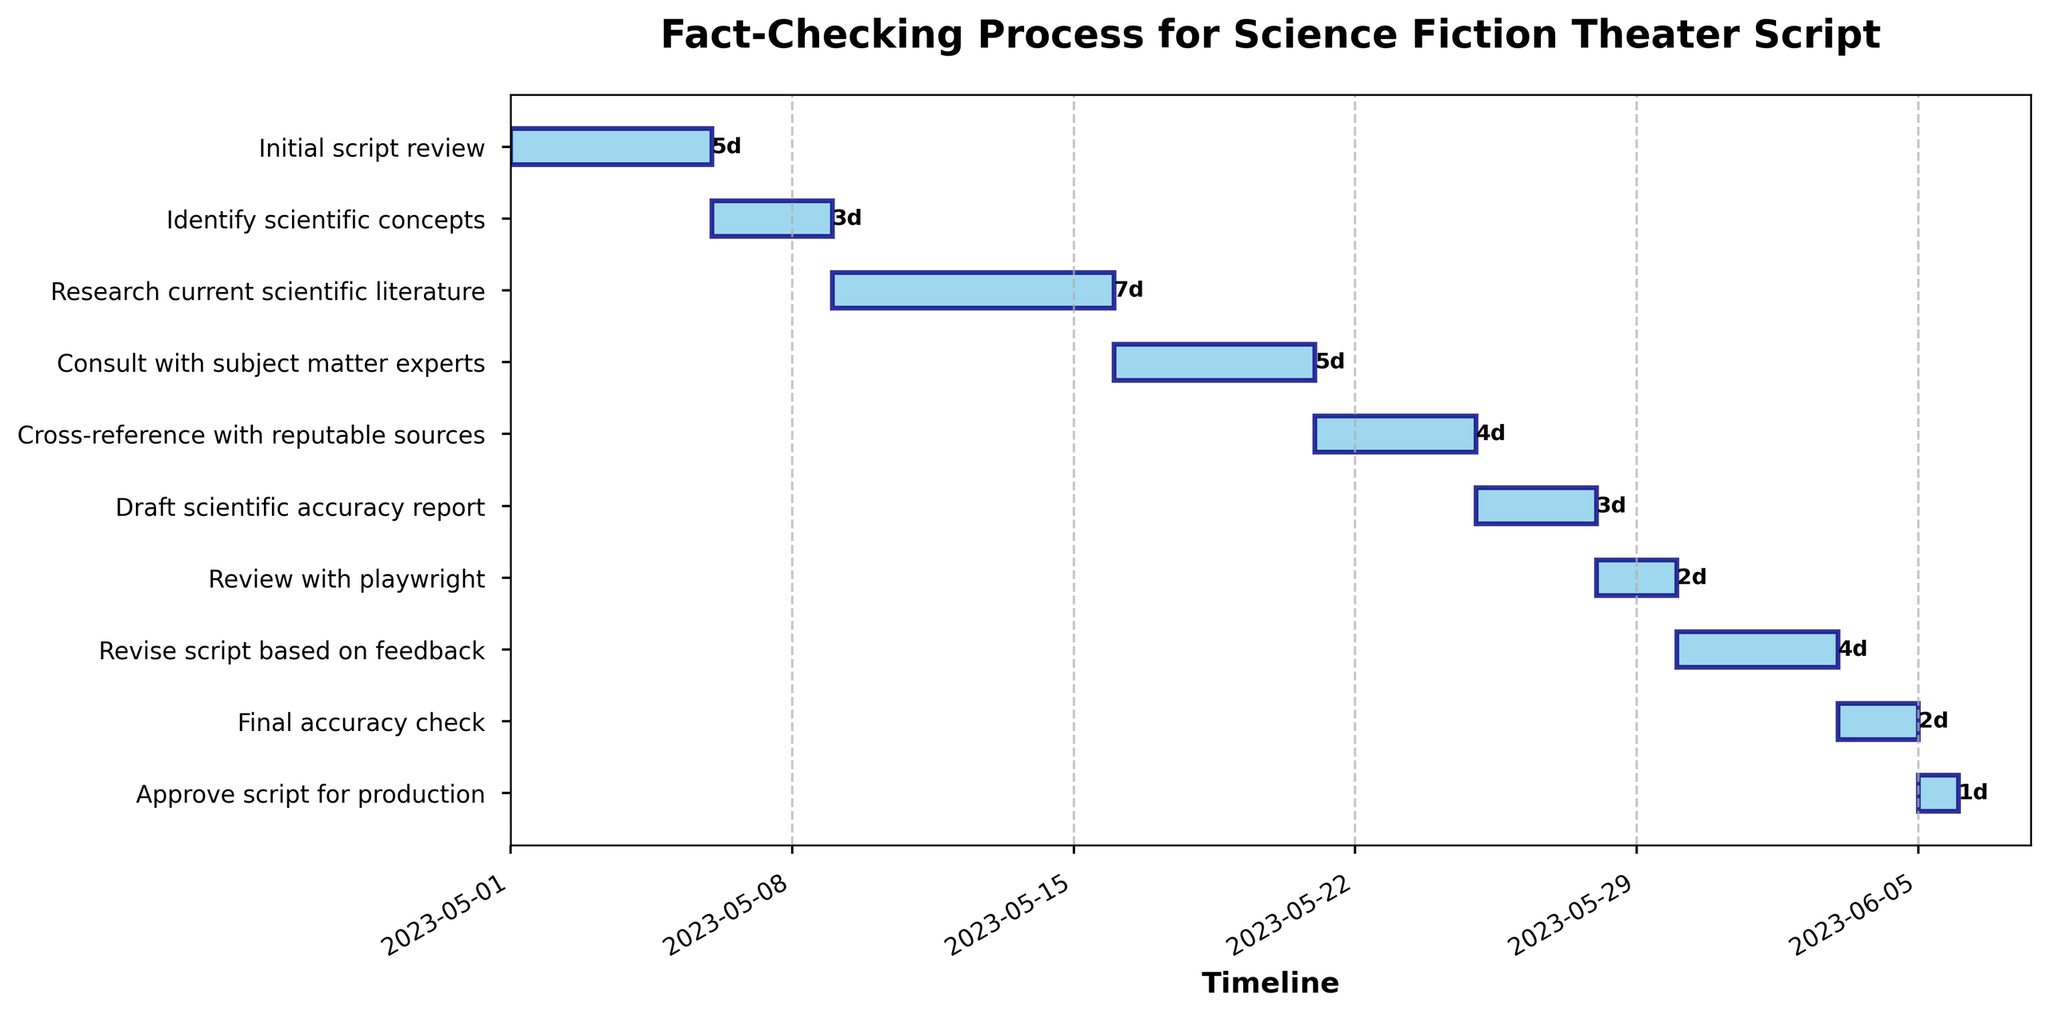What is the title of the Gantt chart? The title is found at the top of the chart and reads "Fact-Checking Process for Science Fiction Theater Script".
Answer: Fact-Checking Process for Science Fiction Theater Script What color are the bars representing each stage of the process? The bars are mostly light blue with some transparency.
Answer: light blue How many tasks are shown in the chart? There are 10 tasks, as indicated by the number of horizontal bars.
Answer: 10 When does the "Initial script review" task start? The task starts on May 1, 2023, as read from the chart's timeline and the label on the y-axis.
Answer: May 1, 2023 Which task has the longest duration? "Research current scientific literature" has the longest duration as its bar is the longest.
Answer: Research current scientific literature What is the start date of the "Final accuracy check"? The start date can be found by locating the "Final accuracy check" bar, which starts on June 3, 2023.
Answer: June 3, 2023 Which tasks take exactly 3 days to complete? By examining the duration labels on the right side of the bars, "Identify scientific concepts" and "Draft scientific accuracy report" both take 3 days.
Answer: Identify scientific concepts, Draft scientific accuracy report Which task overlaps with the "Research current scientific literature"? There is no overlap since the next task, "Consult with subject matter experts," starts after "Research current scientific literature" ends.
Answer: None What is the total duration from the start of the "Initial script review" to the "Approve script for production"? The duration is from May 1, 2023, to June 5, 2023, calculated as June 5, 2023 - May 1, 2023, which is 36 days.
Answer: 36 days How many tasks are scheduled to start after May 20, 2023? By checking the start dates, the tasks starting after May 20, 2023, are "Cross-reference with reputable sources," "Draft scientific accuracy report," "Review with playwright," "Revise script based on feedback," "Final accuracy check," and "Approve script for production," totaling 6 tasks.
Answer: 6 